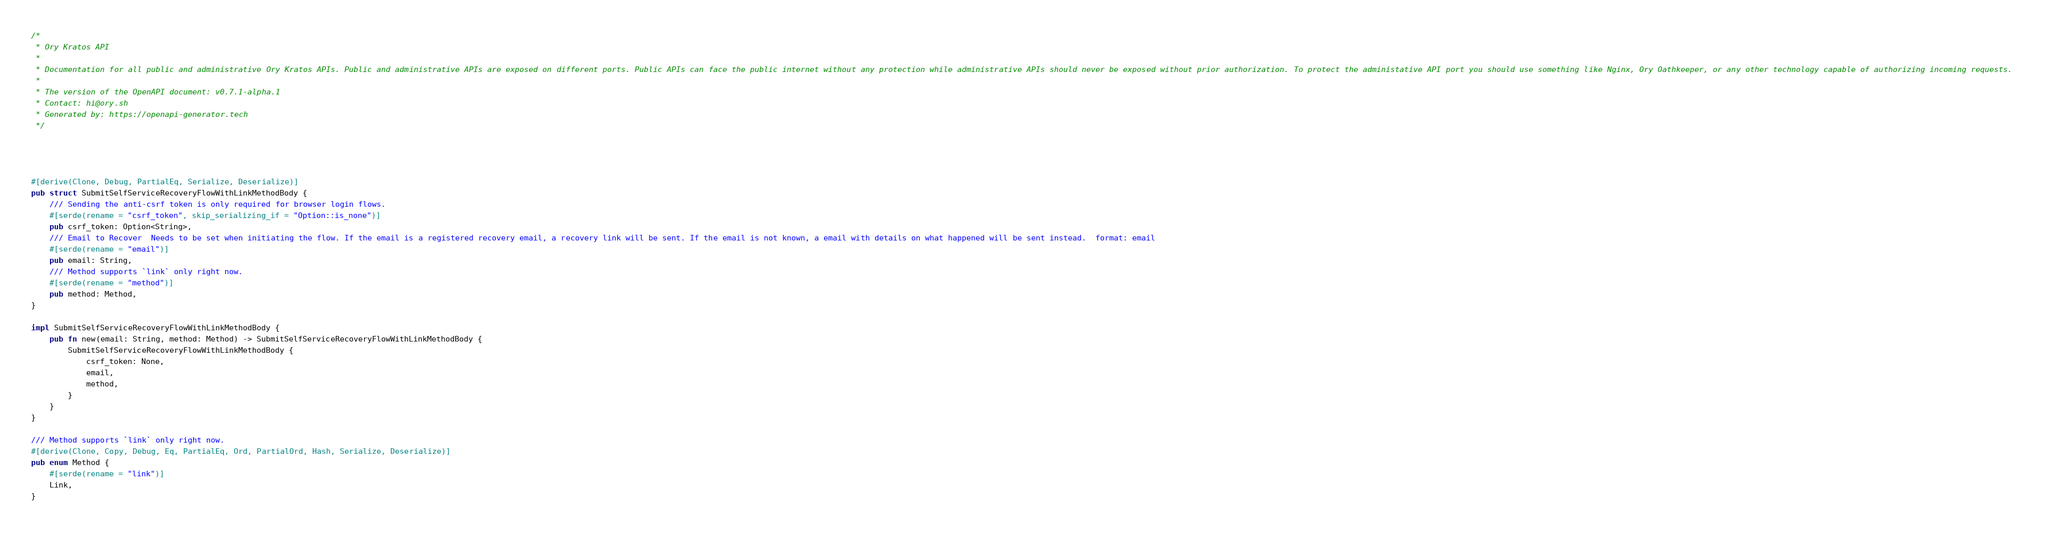Convert code to text. <code><loc_0><loc_0><loc_500><loc_500><_Rust_>/*
 * Ory Kratos API
 *
 * Documentation for all public and administrative Ory Kratos APIs. Public and administrative APIs are exposed on different ports. Public APIs can face the public internet without any protection while administrative APIs should never be exposed without prior authorization. To protect the administative API port you should use something like Nginx, Ory Oathkeeper, or any other technology capable of authorizing incoming requests. 
 *
 * The version of the OpenAPI document: v0.7.1-alpha.1
 * Contact: hi@ory.sh
 * Generated by: https://openapi-generator.tech
 */




#[derive(Clone, Debug, PartialEq, Serialize, Deserialize)]
pub struct SubmitSelfServiceRecoveryFlowWithLinkMethodBody {
    /// Sending the anti-csrf token is only required for browser login flows.
    #[serde(rename = "csrf_token", skip_serializing_if = "Option::is_none")]
    pub csrf_token: Option<String>,
    /// Email to Recover  Needs to be set when initiating the flow. If the email is a registered recovery email, a recovery link will be sent. If the email is not known, a email with details on what happened will be sent instead.  format: email
    #[serde(rename = "email")]
    pub email: String,
    /// Method supports `link` only right now.
    #[serde(rename = "method")]
    pub method: Method,
}

impl SubmitSelfServiceRecoveryFlowWithLinkMethodBody {
    pub fn new(email: String, method: Method) -> SubmitSelfServiceRecoveryFlowWithLinkMethodBody {
        SubmitSelfServiceRecoveryFlowWithLinkMethodBody {
            csrf_token: None,
            email,
            method,
        }
    }
}

/// Method supports `link` only right now.
#[derive(Clone, Copy, Debug, Eq, PartialEq, Ord, PartialOrd, Hash, Serialize, Deserialize)]
pub enum Method {
    #[serde(rename = "link")]
    Link,
}

</code> 